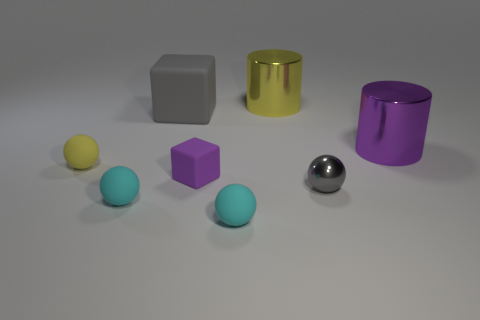What number of gray matte things are on the right side of the purple object that is in front of the small sphere behind the tiny purple rubber thing?
Give a very brief answer. 0. There is a small yellow rubber object in front of the big yellow thing; is it the same shape as the small gray shiny object?
Provide a short and direct response. Yes. How many objects are yellow rubber balls or big gray matte things left of the big purple shiny thing?
Offer a very short reply. 2. Is the number of yellow spheres that are on the right side of the small yellow object greater than the number of large purple cubes?
Provide a short and direct response. No. Are there the same number of small gray shiny spheres that are on the left side of the big yellow shiny cylinder and big metal objects in front of the small gray metallic sphere?
Offer a terse response. Yes. Are there any large cylinders that are left of the gray thing in front of the large purple shiny cylinder?
Offer a terse response. Yes. There is a big yellow thing; what shape is it?
Offer a terse response. Cylinder. The rubber block that is the same color as the small shiny object is what size?
Give a very brief answer. Large. What is the size of the yellow object that is left of the matte cube left of the purple cube?
Give a very brief answer. Small. What is the size of the cyan rubber sphere that is to the left of the tiny purple matte object?
Your answer should be compact. Small. 